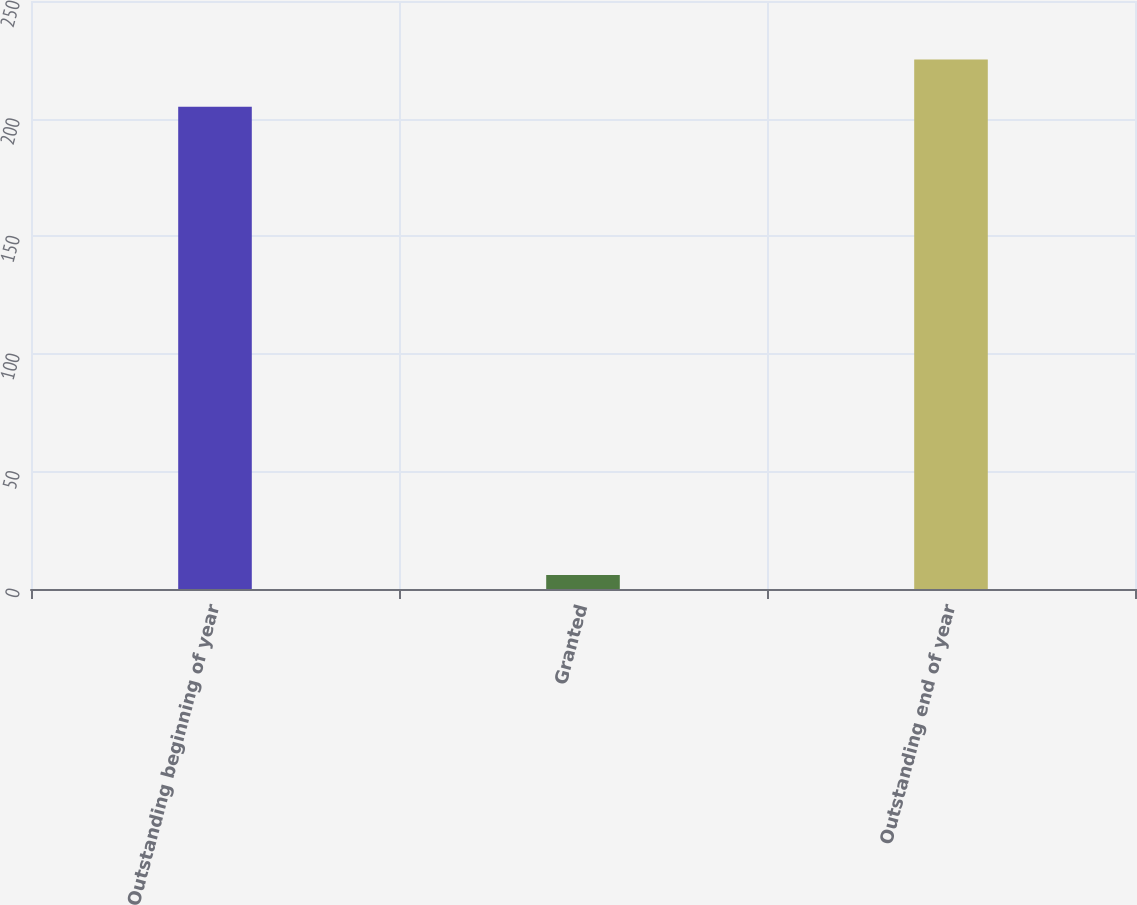Convert chart to OTSL. <chart><loc_0><loc_0><loc_500><loc_500><bar_chart><fcel>Outstanding beginning of year<fcel>Granted<fcel>Outstanding end of year<nl><fcel>205<fcel>6<fcel>225.1<nl></chart> 